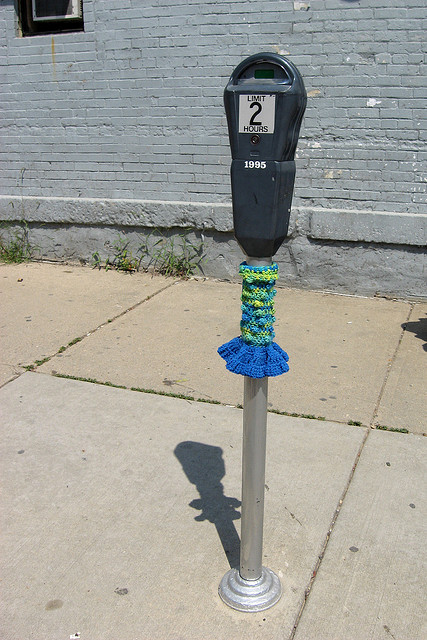Identify the text displayed in this image. LIMIT 2 HOURS 1995 